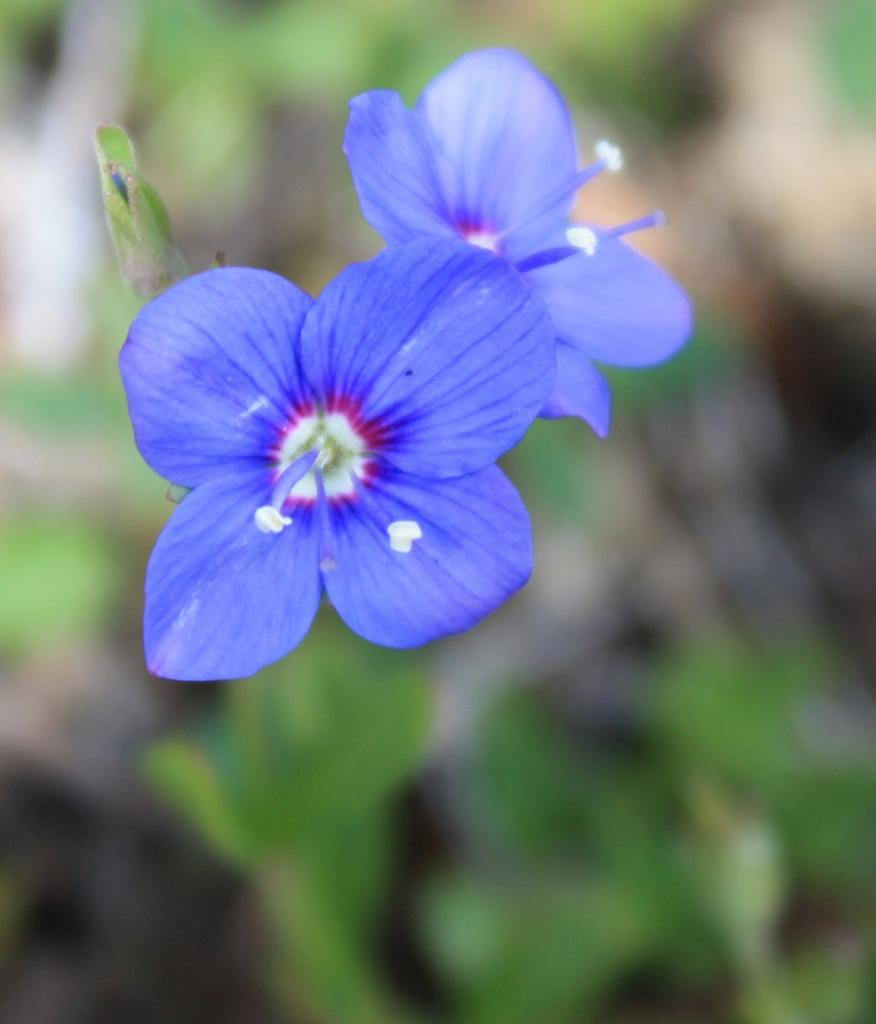What type of flowers are present in the image? There are blue color flowers in the image. Can you describe the background of the image? The background of the image is blurred. What type of flag is being waved during the holiday in the image? There is no flag or holiday present in the image; it only features blue color flowers and a blurred background. 